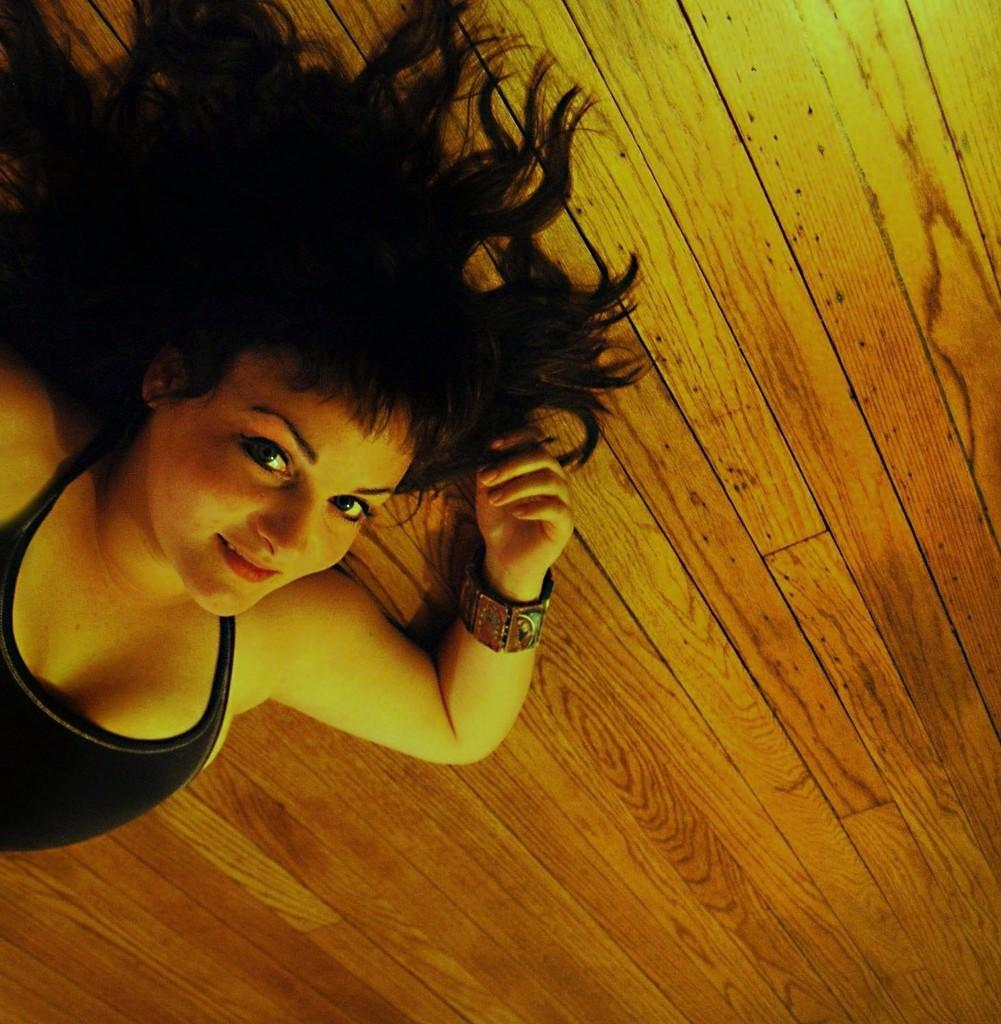Who is the main subject in the image? There is a woman in the image. What is the woman wearing? The woman is wearing a black dress. What is the woman laying on in the image? The woman is laying on a wooden surface. What is the color of the wooden surface? The wooden surface is brown in color. What type of government is depicted in the image? There is no government depicted in the image; it features a woman laying on a wooden surface. What kind of shoes is the woman wearing in the image? The woman is not wearing any shoes in the image; she is laying on a wooden surface. 